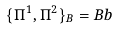Convert formula to latex. <formula><loc_0><loc_0><loc_500><loc_500>\{ \Pi ^ { 1 } , \Pi ^ { 2 } \} _ { B } = B b</formula> 